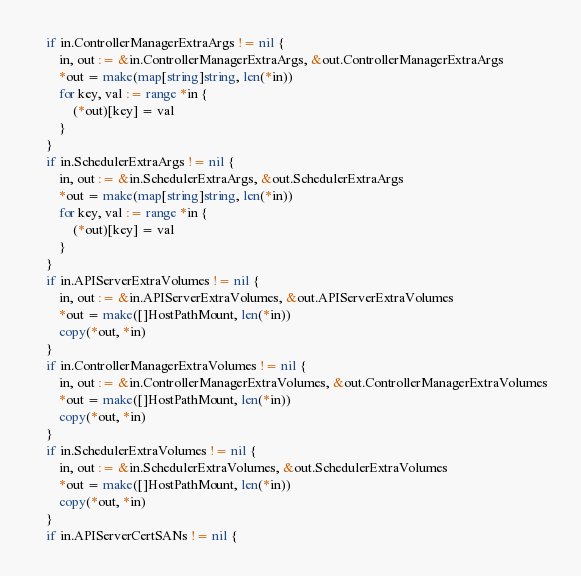Convert code to text. <code><loc_0><loc_0><loc_500><loc_500><_Go_>	if in.ControllerManagerExtraArgs != nil {
		in, out := &in.ControllerManagerExtraArgs, &out.ControllerManagerExtraArgs
		*out = make(map[string]string, len(*in))
		for key, val := range *in {
			(*out)[key] = val
		}
	}
	if in.SchedulerExtraArgs != nil {
		in, out := &in.SchedulerExtraArgs, &out.SchedulerExtraArgs
		*out = make(map[string]string, len(*in))
		for key, val := range *in {
			(*out)[key] = val
		}
	}
	if in.APIServerExtraVolumes != nil {
		in, out := &in.APIServerExtraVolumes, &out.APIServerExtraVolumes
		*out = make([]HostPathMount, len(*in))
		copy(*out, *in)
	}
	if in.ControllerManagerExtraVolumes != nil {
		in, out := &in.ControllerManagerExtraVolumes, &out.ControllerManagerExtraVolumes
		*out = make([]HostPathMount, len(*in))
		copy(*out, *in)
	}
	if in.SchedulerExtraVolumes != nil {
		in, out := &in.SchedulerExtraVolumes, &out.SchedulerExtraVolumes
		*out = make([]HostPathMount, len(*in))
		copy(*out, *in)
	}
	if in.APIServerCertSANs != nil {</code> 